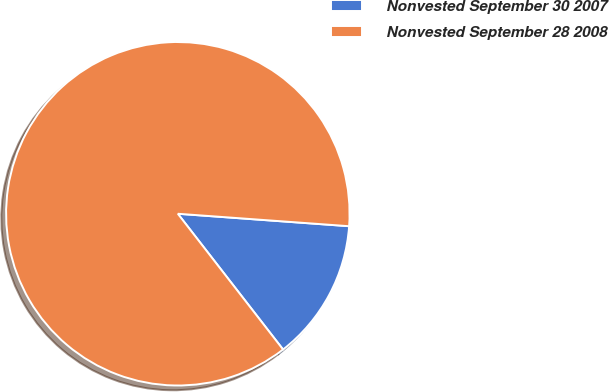Convert chart to OTSL. <chart><loc_0><loc_0><loc_500><loc_500><pie_chart><fcel>Nonvested September 30 2007<fcel>Nonvested September 28 2008<nl><fcel>13.35%<fcel>86.65%<nl></chart> 